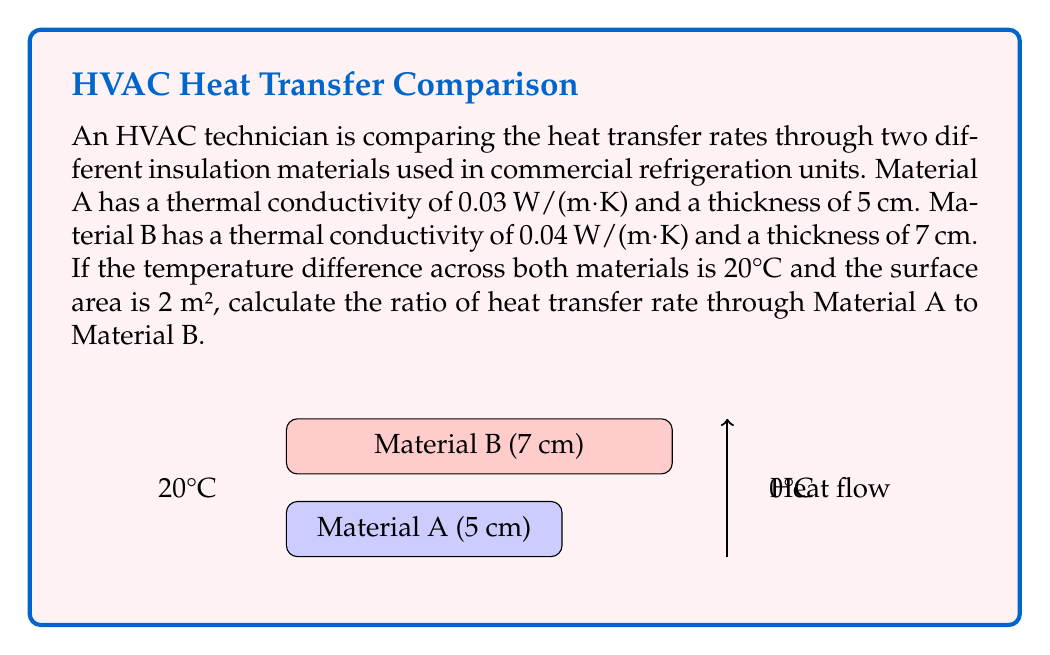Provide a solution to this math problem. To solve this problem, we'll use Fourier's Law of Heat Conduction:

$$ Q = -kA\frac{dT}{dx} $$

Where:
$Q$ = heat transfer rate (W)
$k$ = thermal conductivity (W/(m·K))
$A$ = surface area (m²)
$dT$ = temperature difference (K or °C)
$dx$ = material thickness (m)

For steady-state conditions, we can simplify this to:

$$ Q = \frac{kA\Delta T}{L} $$

Where $L$ is the thickness of the material.

Step 1: Calculate heat transfer rate for Material A
$$ Q_A = \frac{k_A A \Delta T}{L_A} = \frac{0.03 \times 2 \times 20}{0.05} = 24 \text{ W} $$

Step 2: Calculate heat transfer rate for Material B
$$ Q_B = \frac{k_B A \Delta T}{L_B} = \frac{0.04 \times 2 \times 20}{0.07} = 22.86 \text{ W} $$

Step 3: Calculate the ratio of heat transfer rates
$$ \text{Ratio} = \frac{Q_A}{Q_B} = \frac{24}{22.86} \approx 1.05 $$

Therefore, the ratio of heat transfer rate through Material A to Material B is approximately 1.05.
Answer: 1.05 